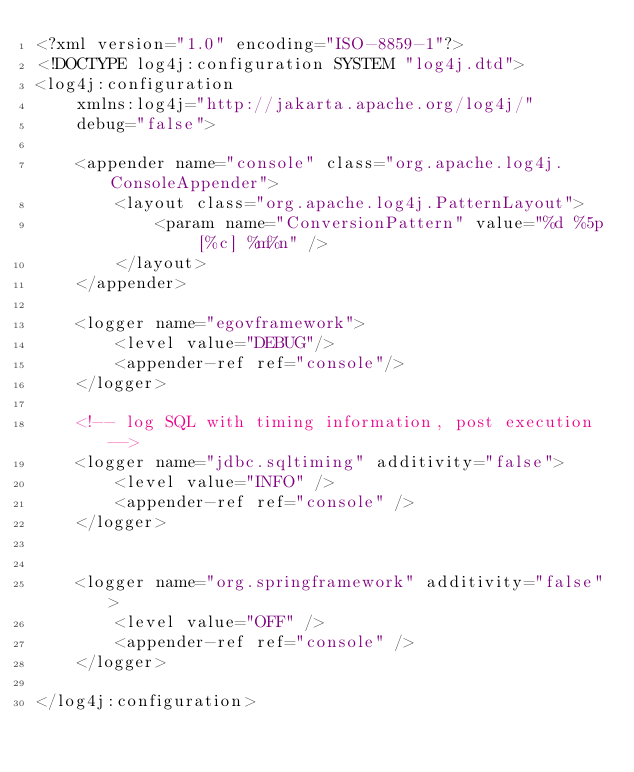<code> <loc_0><loc_0><loc_500><loc_500><_XML_><?xml version="1.0" encoding="ISO-8859-1"?>
<!DOCTYPE log4j:configuration SYSTEM "log4j.dtd">
<log4j:configuration 
    xmlns:log4j="http://jakarta.apache.org/log4j/" 
    debug="false">
    
    <appender name="console" class="org.apache.log4j.ConsoleAppender">
        <layout class="org.apache.log4j.PatternLayout">
            <param name="ConversionPattern" value="%d %5p [%c] %m%n" />
        </layout>   
    </appender>
    
    <logger name="egovframework">
        <level value="DEBUG"/>
        <appender-ref ref="console"/>
    </logger>

	<!-- log SQL with timing information, post execution -->
	<logger name="jdbc.sqltiming" additivity="false">
		<level value="INFO" />
		<appender-ref ref="console" />
	</logger>
 
	
	<logger name="org.springframework" additivity="false">
		<level value="OFF" />
		<appender-ref ref="console" />
	</logger>
	                   
</log4j:configuration>
</code> 